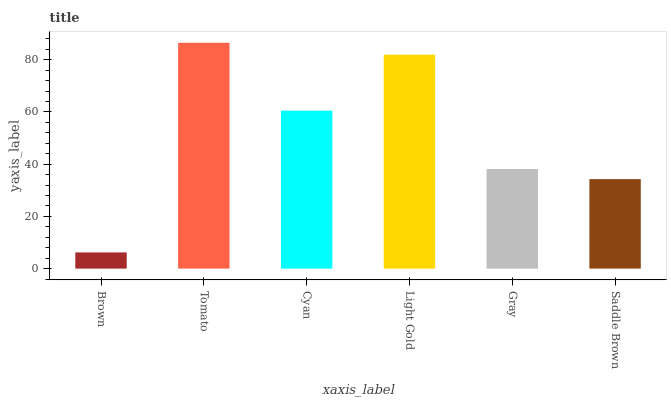Is Brown the minimum?
Answer yes or no. Yes. Is Tomato the maximum?
Answer yes or no. Yes. Is Cyan the minimum?
Answer yes or no. No. Is Cyan the maximum?
Answer yes or no. No. Is Tomato greater than Cyan?
Answer yes or no. Yes. Is Cyan less than Tomato?
Answer yes or no. Yes. Is Cyan greater than Tomato?
Answer yes or no. No. Is Tomato less than Cyan?
Answer yes or no. No. Is Cyan the high median?
Answer yes or no. Yes. Is Gray the low median?
Answer yes or no. Yes. Is Gray the high median?
Answer yes or no. No. Is Light Gold the low median?
Answer yes or no. No. 